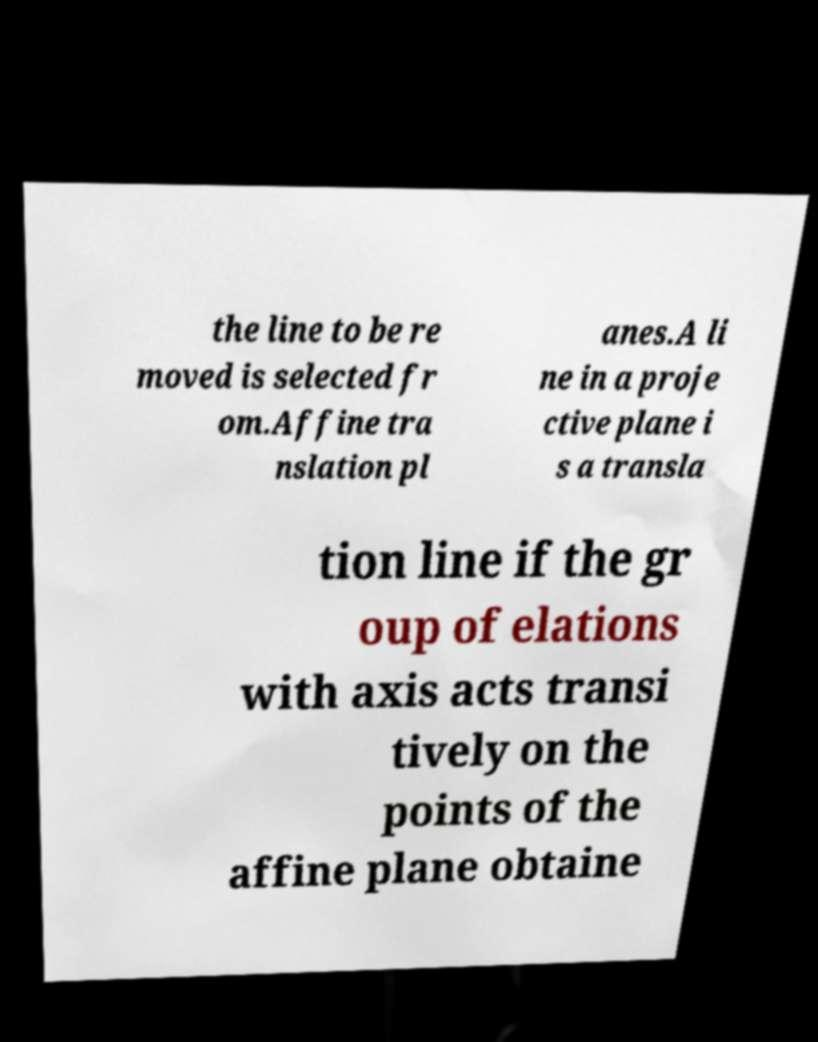There's text embedded in this image that I need extracted. Can you transcribe it verbatim? the line to be re moved is selected fr om.Affine tra nslation pl anes.A li ne in a proje ctive plane i s a transla tion line if the gr oup of elations with axis acts transi tively on the points of the affine plane obtaine 